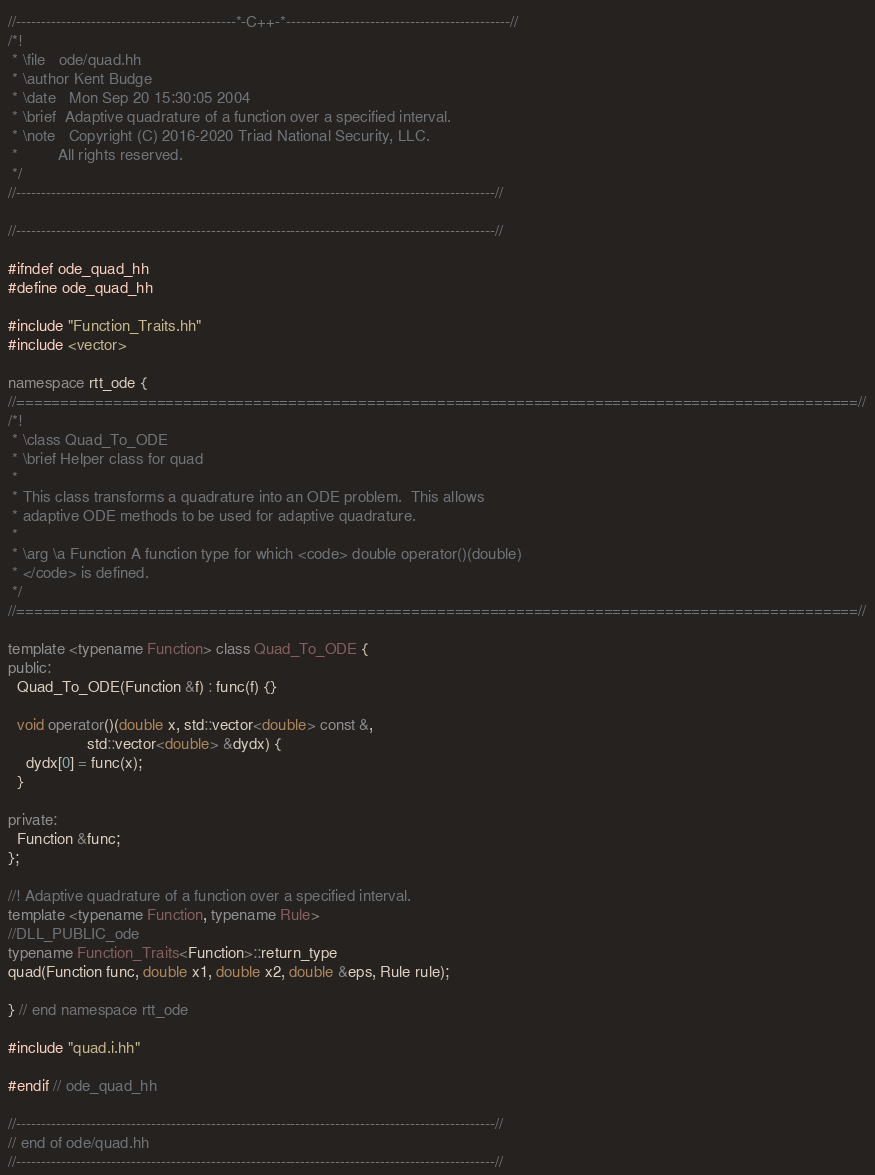Convert code to text. <code><loc_0><loc_0><loc_500><loc_500><_C++_>//--------------------------------------------*-C++-*---------------------------------------------//
/*!
 * \file   ode/quad.hh
 * \author Kent Budge
 * \date   Mon Sep 20 15:30:05 2004
 * \brief  Adaptive quadrature of a function over a specified interval.
 * \note   Copyright (C) 2016-2020 Triad National Security, LLC.
 *         All rights reserved.
 */
//------------------------------------------------------------------------------------------------//

//------------------------------------------------------------------------------------------------//

#ifndef ode_quad_hh
#define ode_quad_hh

#include "Function_Traits.hh"
#include <vector>

namespace rtt_ode {
//================================================================================================//
/*! 
 * \class Quad_To_ODE
 * \brief Helper class for quad
 *
 * This class transforms a quadrature into an ODE problem.  This allows
 * adaptive ODE methods to be used for adaptive quadrature.
 *
 * \arg \a Function A function type for which <code> double operator()(double)
 * </code> is defined.
 */
//================================================================================================//

template <typename Function> class Quad_To_ODE {
public:
  Quad_To_ODE(Function &f) : func(f) {}

  void operator()(double x, std::vector<double> const &,
                  std::vector<double> &dydx) {
    dydx[0] = func(x);
  }

private:
  Function &func;
};

//! Adaptive quadrature of a function over a specified interval.
template <typename Function, typename Rule>
//DLL_PUBLIC_ode
typename Function_Traits<Function>::return_type
quad(Function func, double x1, double x2, double &eps, Rule rule);

} // end namespace rtt_ode

#include "quad.i.hh"

#endif // ode_quad_hh

//------------------------------------------------------------------------------------------------//
// end of ode/quad.hh
//------------------------------------------------------------------------------------------------//
</code> 